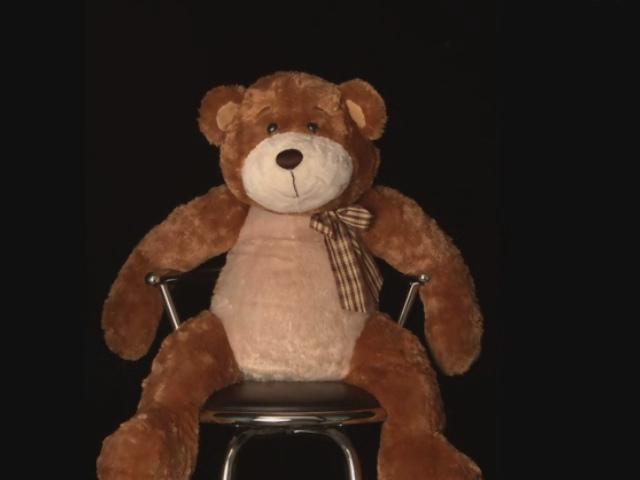How many people are wearing an orange tee shirt?
Give a very brief answer. 0. 